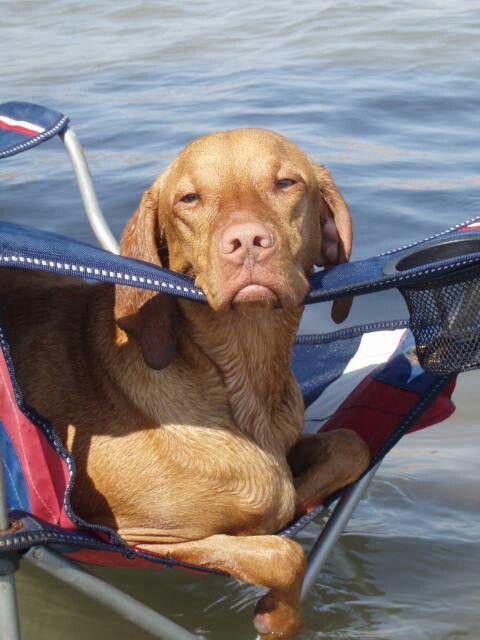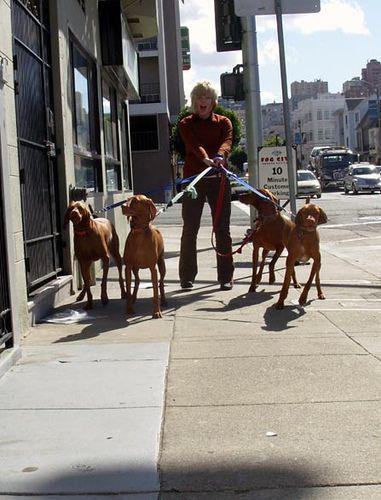The first image is the image on the left, the second image is the image on the right. Examine the images to the left and right. Is the description "There are exactly two live dogs." accurate? Answer yes or no. No. The first image is the image on the left, the second image is the image on the right. Evaluate the accuracy of this statement regarding the images: "One image shows a single dog, which has short reddish-orange fur and is standing on an elevated platform with its body turned forward.". Is it true? Answer yes or no. No. 